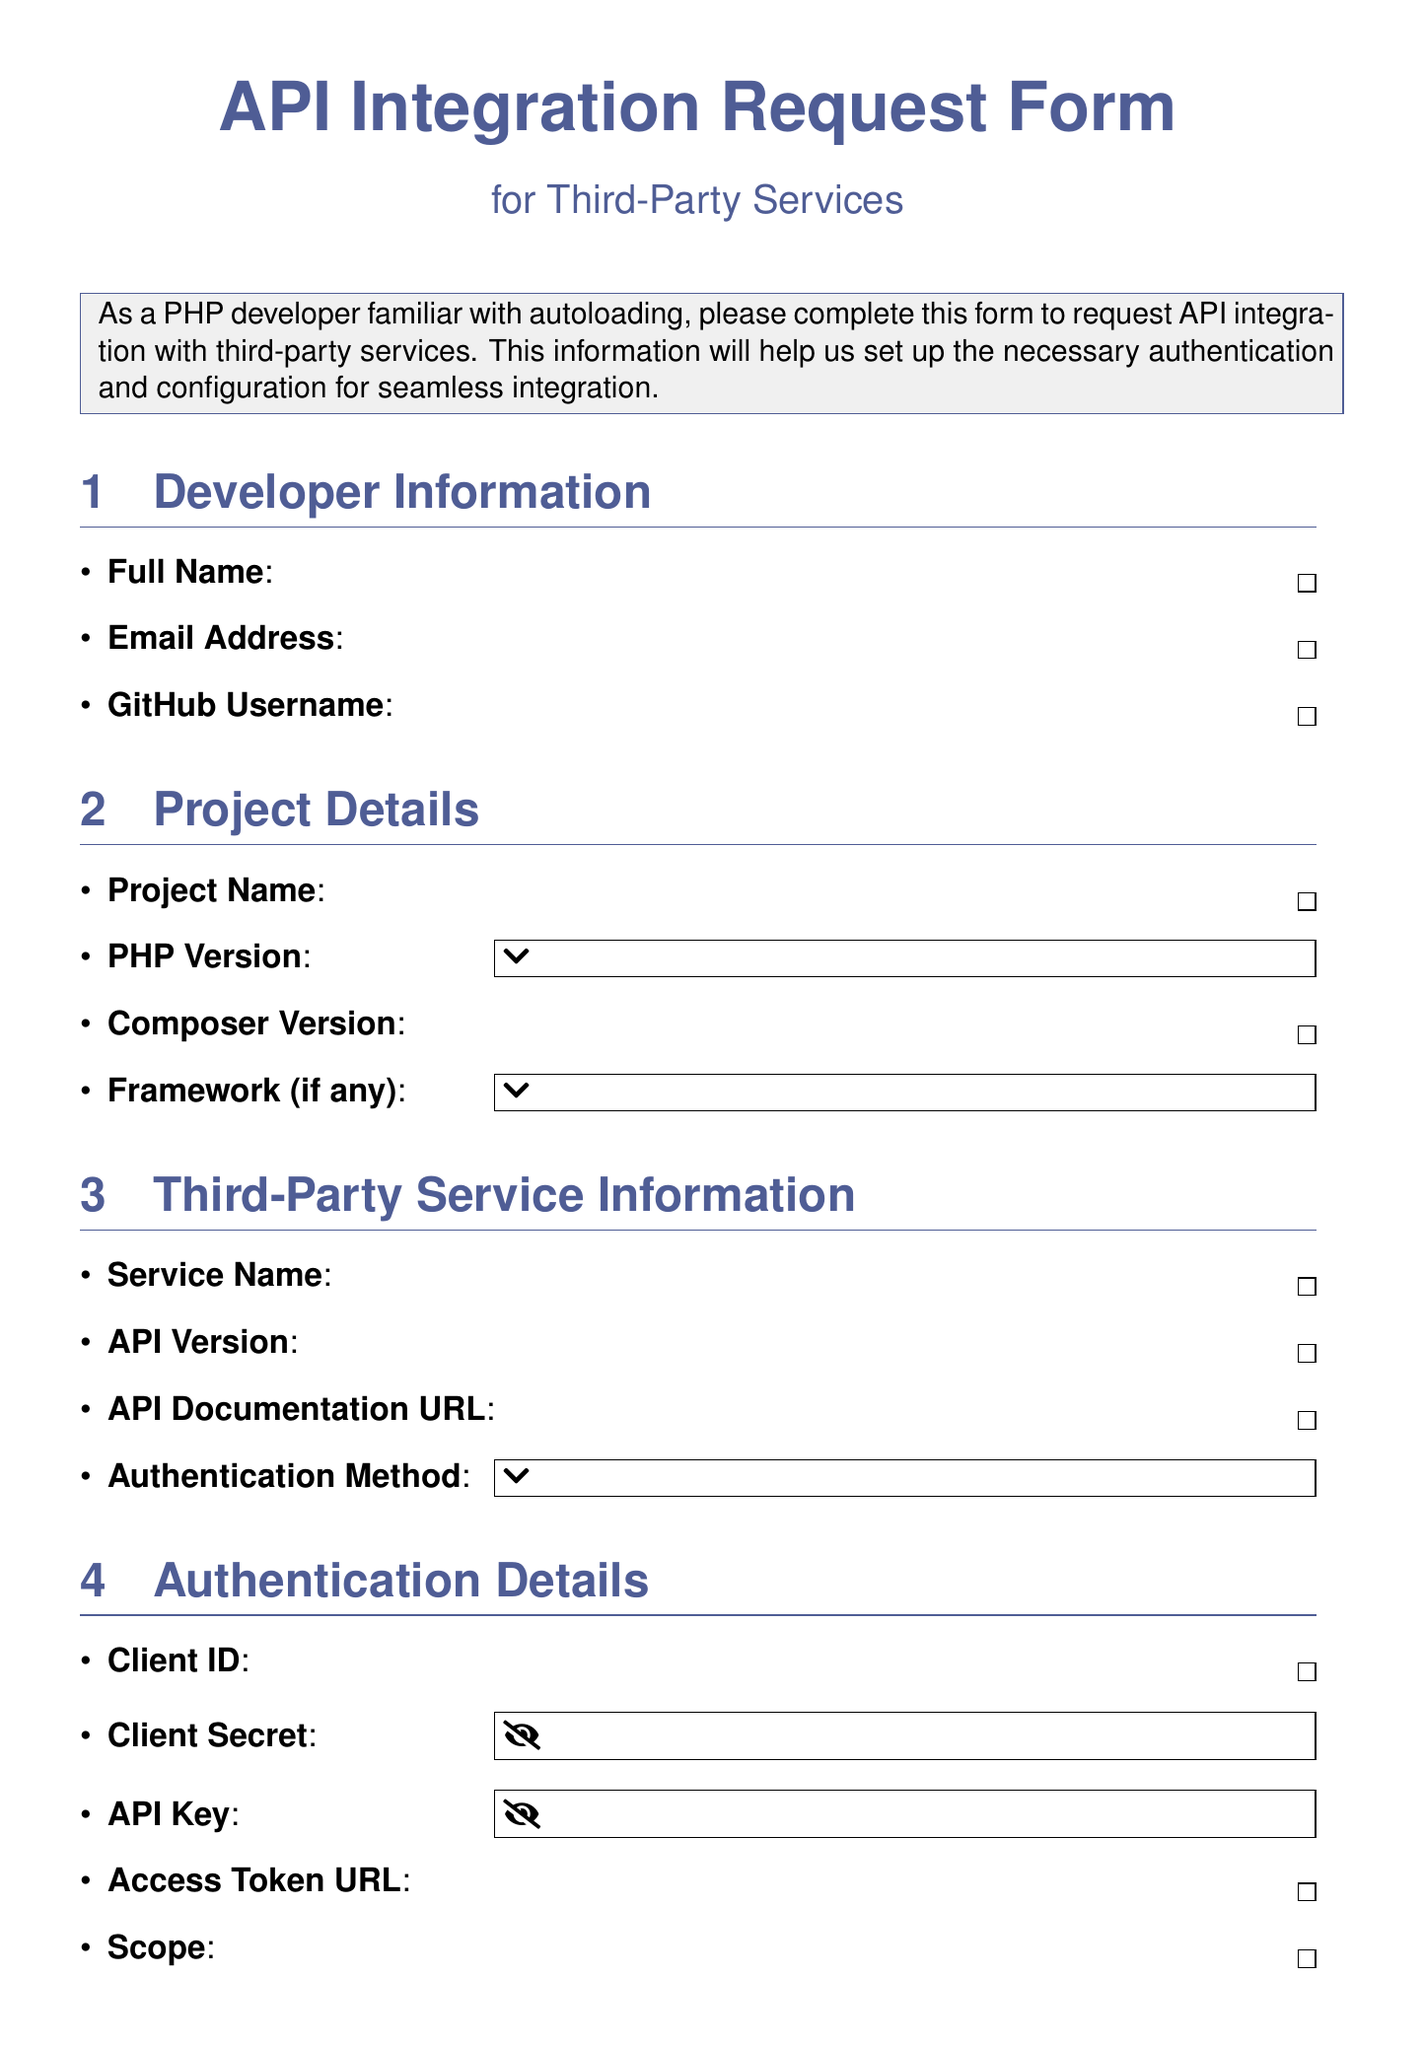what is the title of the form? The title of the form is presented at the top of the document, labeled clearly.
Answer: API Integration Request Form for Third-Party Services what is the required PHP version for the project? The form includes a selection of PHP versions that are required for the project.
Answer: 7.4, 8.0, 8.1, 8.2 what information is required for the "Service Name"? The form specifies that each section contains fields that need specific information, including this one.
Answer: Yes which frameworks are listed as options in the project details section? The frameworks section gives options to choose from for the project details.
Answer: Laravel, Symfony, CodeIgniter, Zend, Other, None what type of authentication methods are available to select from? The document lists several methods for authentication, which are crucial for API integration.
Answer: OAuth 2.0, API Key, JWT, Basic Auth, Other what is the preferred completion date? This field requires a date input from the developer in the additional information section.
Answer: Required what is the section dedicated to PHP integration specifics? The document has structured sections, and one specifically addresses PHP-related integration aspects.
Answer: PHP Integration Specifics how many total fields are present in the "Authentication Details" section? The document lists the number of fields under each specific section clearly.
Answer: Five which HTTP clients are suggested for integration preferences? The form offers selections for preferred HTTP clients for the integration, indicating choices available.
Answer: Guzzle, cURL, Symfony HTTP Client, Other 